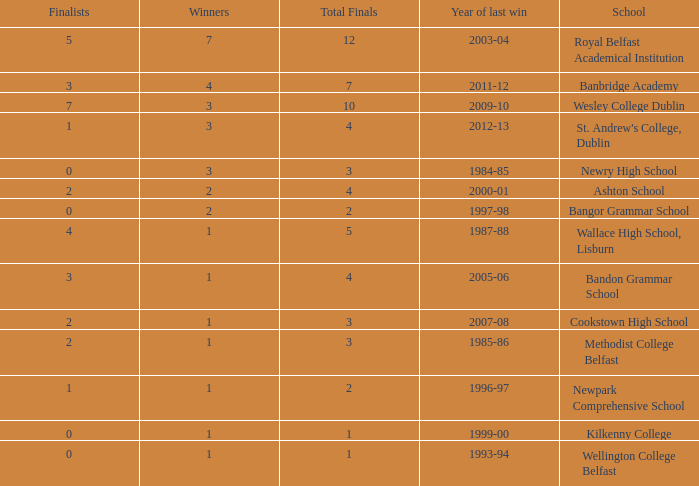In what year was the total finals at 10? 2009-10. 